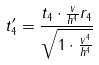<formula> <loc_0><loc_0><loc_500><loc_500>t _ { 4 } ^ { \prime } = \frac { t _ { 4 } \cdot \frac { v } { h ^ { 4 } } r _ { 4 } } { \sqrt { 1 \cdot \frac { v ^ { 4 } } { h ^ { 4 } } } }</formula> 